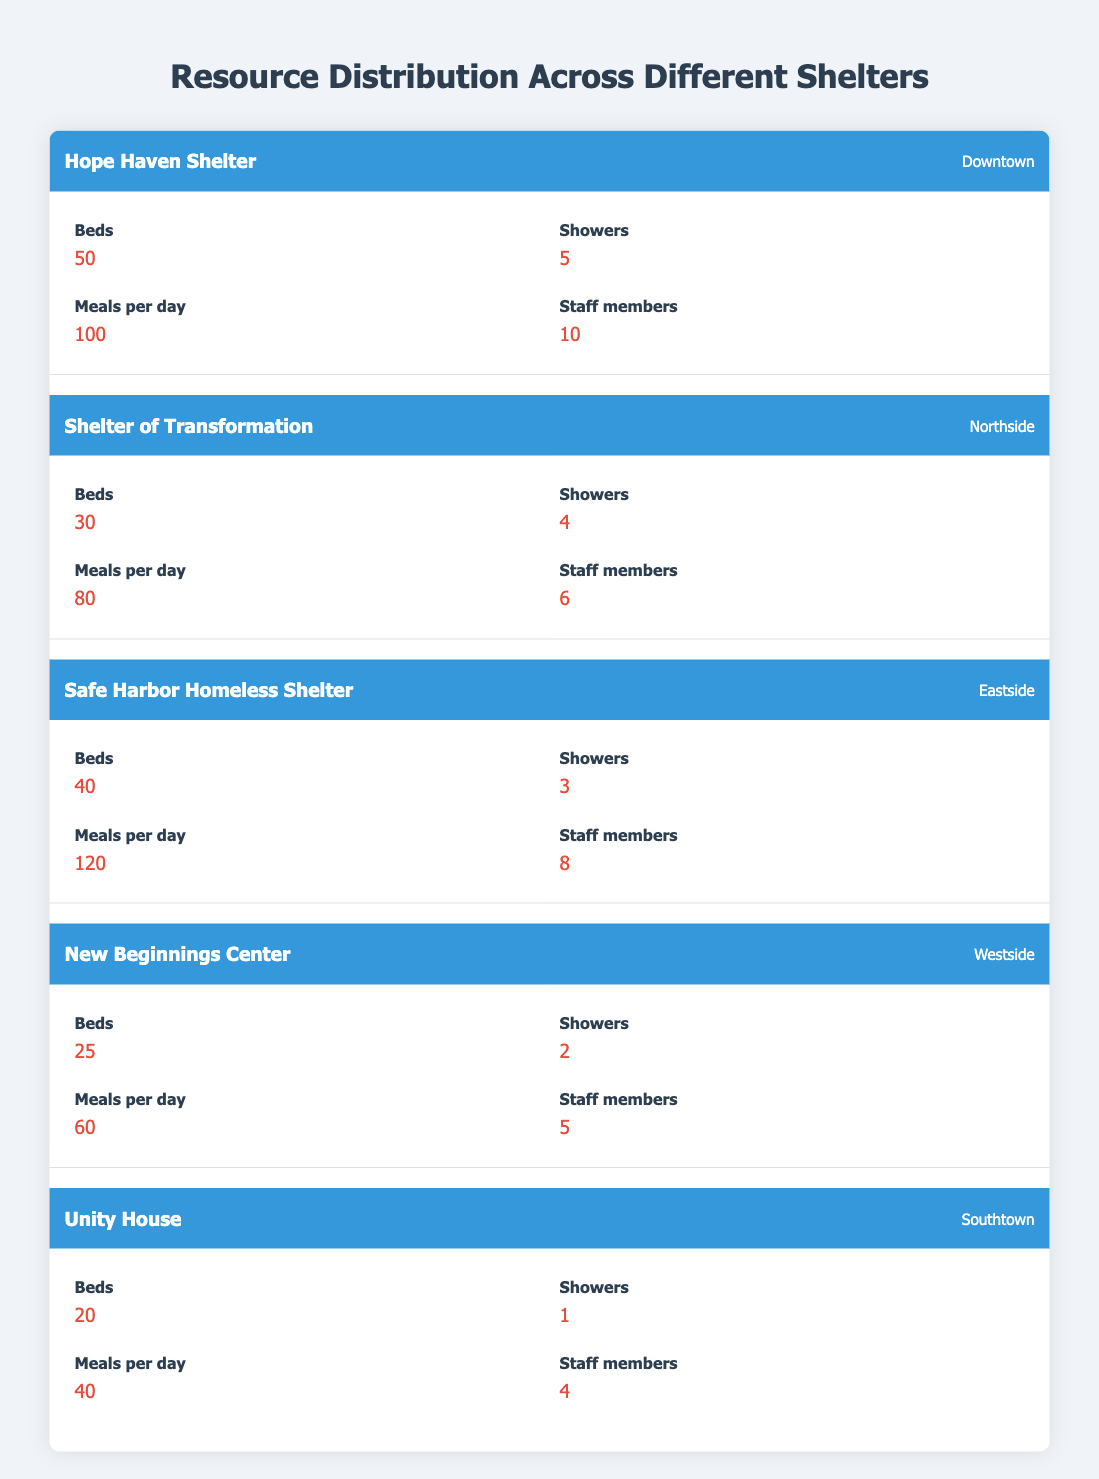What is the total number of beds available across all shelters? To find the total number of beds, sum the bed counts from each shelter: 50 (Hope Haven) + 30 (Shelter of Transformation) + 40 (Safe Harbor) + 25 (New Beginnings) + 20 (Unity House) = 195.
Answer: 195 Which shelter has the highest number of meals served per day? By comparing the meals served per day: Hope Haven (100), Shelter of Transformation (80), Safe Harbor (120), New Beginnings (60), and Unity House (40), Safe Harbor has the highest with 120 meals.
Answer: Safe Harbor Homeless Shelter How many more showers does Hope Haven Shelter have than Unity House? To find the difference in showers: Hope Haven has 5 showers and Unity House has 1 shower. The difference is 5 - 1 = 4.
Answer: 4 Is there a shelter that provides fewer than 3 showers? A quick look shows New Beginnings has 2 showers and Unity House has 1 shower, which are both fewer than 3. Therefore, yes, there are shelters with fewer than 3 showers.
Answer: Yes What is the average number of staff members across all shelters? To calculate the average, first sum the staff members: 10 (Hope Haven) + 6 (Shelter of Transformation) + 8 (Safe Harbor) + 5 (New Beginnings) + 4 (Unity House) = 33. Then divide by the number of shelters (5): 33 / 5 = 6.6.
Answer: 6.6 Which shelter has both the lowest number of beds and the lowest number of meals served per day? Looking at the bed counts: Unity House has the fewest beds at 20 and meals served at 40, which are both the lowest counts, confirming this shelter has both minimum values.
Answer: Unity House How many staff members does the shelter with the most beds have? The shelter with the most beds is Hope Haven with 50 beds, and it has 10 staff members.
Answer: 10 Are there more total resources (beds, showers, meals, staff) in Safe Harbor than Unity House? Safe Harbor has 40 beds + 3 showers + 120 meals + 8 staff = 171 total resources. Unity House has 20 beds + 1 shower + 40 meals + 4 staff = 65 total resources. Since 171 > 65, the answer is yes.
Answer: Yes What percentage of meals provided per day does Safe Harbor account for out of the total meals served by all shelters? First, find the total meals served: 100 + 80 + 120 + 60 + 40 = 400 meals. Safe Harbor serves 120 meals, so the percentage is (120 / 400) * 100 = 30%.
Answer: 30% 